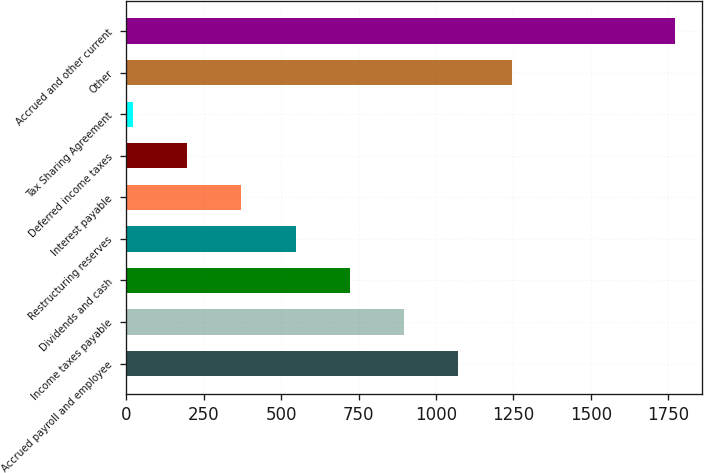Convert chart. <chart><loc_0><loc_0><loc_500><loc_500><bar_chart><fcel>Accrued payroll and employee<fcel>Income taxes payable<fcel>Dividends and cash<fcel>Restructuring reserves<fcel>Interest payable<fcel>Deferred income taxes<fcel>Tax Sharing Agreement<fcel>Other<fcel>Accrued and other current<nl><fcel>1071.6<fcel>896.5<fcel>721.4<fcel>546.3<fcel>371.2<fcel>196.1<fcel>21<fcel>1246.7<fcel>1772<nl></chart> 